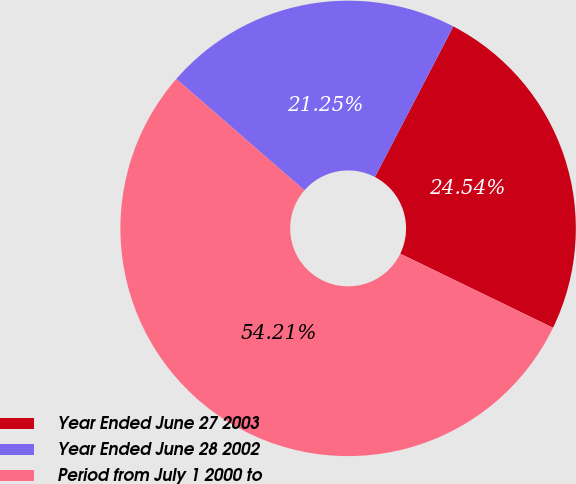<chart> <loc_0><loc_0><loc_500><loc_500><pie_chart><fcel>Year Ended June 27 2003<fcel>Year Ended June 28 2002<fcel>Period from July 1 2000 to<nl><fcel>24.54%<fcel>21.25%<fcel>54.21%<nl></chart> 